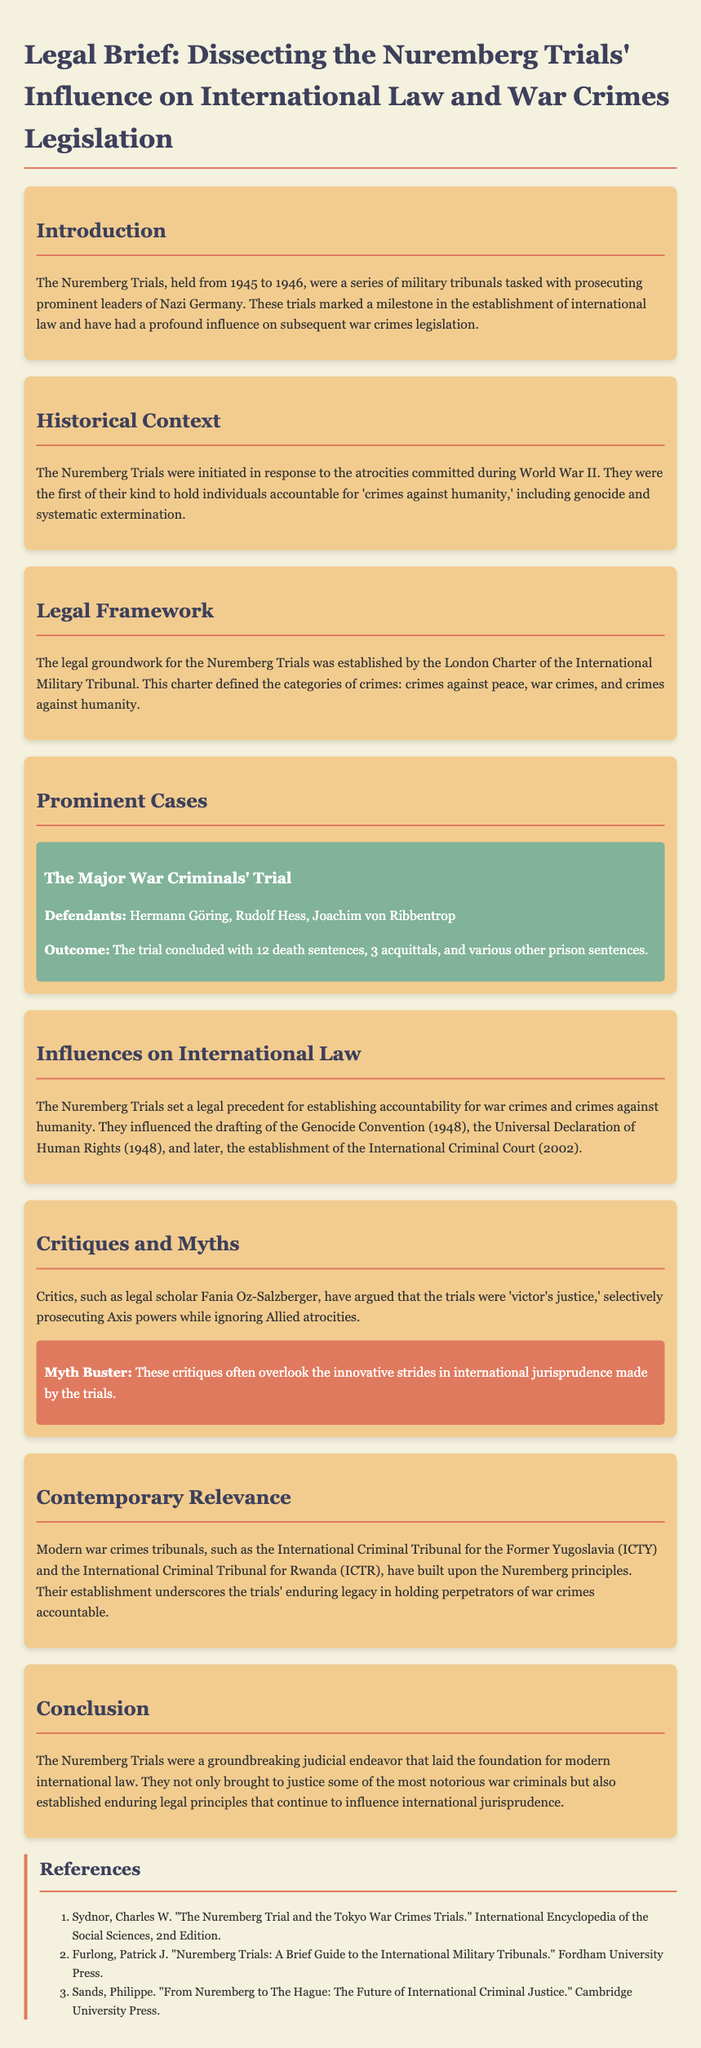What year were the Nuremberg Trials held? The Nuremberg Trials were held from 1945 to 1946, as stated in the introduction.
Answer: 1945 to 1946 Who were the defendants in The Major War Criminals' Trial? The document lists Hermann Göring, Rudolf Hess, and Joachim von Ribbentrop as defendants in the trial.
Answer: Hermann Göring, Rudolf Hess, Joachim von Ribbentrop What was one outcome of The Major War Criminals' Trial? The outcome mentioned includes 12 death sentences, which is a significant result of the trial.
Answer: 12 death sentences What legal document established the framework for the Nuremberg Trials? The London Charter of the International Military Tribunal is identified as the legal framework for the trials.
Answer: London Charter of the International Military Tribunal What principle did the Nuremberg Trials introduce regarding accountability? The trials introduced the principle of accountability for war crimes and crimes against humanity.
Answer: Accountability for war crimes Which convention was influenced by the Nuremberg Trials? The drafting of the Genocide Convention in 1948 was influenced by the Nuremberg Trials.
Answer: Genocide Convention What term is used to describe the type of justice the critics claim the trials represented? Critics, including legal scholars, refer to the trials as 'victor's justice.'
Answer: victor's justice What is the contemporary tribunal mentioned that followed the Nuremberg principles? The International Criminal Tribunal for the Former Yugoslavia (ICTY) is provided as an example of a contemporary tribunal.
Answer: International Criminal Tribunal for the Former Yugoslavia (ICTY) What does the conclusion emphasize about the impact of the Nuremberg Trials? The conclusion emphasizes that the trials laid the foundation for modern international law.
Answer: Foundation for modern international law 